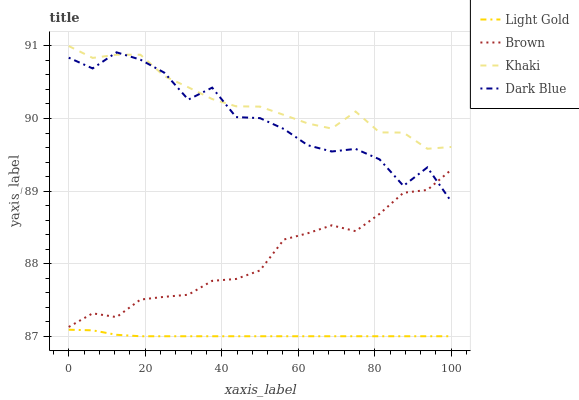Does Light Gold have the minimum area under the curve?
Answer yes or no. Yes. Does Khaki have the maximum area under the curve?
Answer yes or no. Yes. Does Khaki have the minimum area under the curve?
Answer yes or no. No. Does Light Gold have the maximum area under the curve?
Answer yes or no. No. Is Light Gold the smoothest?
Answer yes or no. Yes. Is Dark Blue the roughest?
Answer yes or no. Yes. Is Khaki the smoothest?
Answer yes or no. No. Is Khaki the roughest?
Answer yes or no. No. Does Light Gold have the lowest value?
Answer yes or no. Yes. Does Khaki have the lowest value?
Answer yes or no. No. Does Khaki have the highest value?
Answer yes or no. Yes. Does Light Gold have the highest value?
Answer yes or no. No. Is Brown less than Khaki?
Answer yes or no. Yes. Is Khaki greater than Brown?
Answer yes or no. Yes. Does Brown intersect Dark Blue?
Answer yes or no. Yes. Is Brown less than Dark Blue?
Answer yes or no. No. Is Brown greater than Dark Blue?
Answer yes or no. No. Does Brown intersect Khaki?
Answer yes or no. No. 